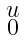Convert formula to latex. <formula><loc_0><loc_0><loc_500><loc_500>\begin{smallmatrix} u \\ 0 \end{smallmatrix}</formula> 